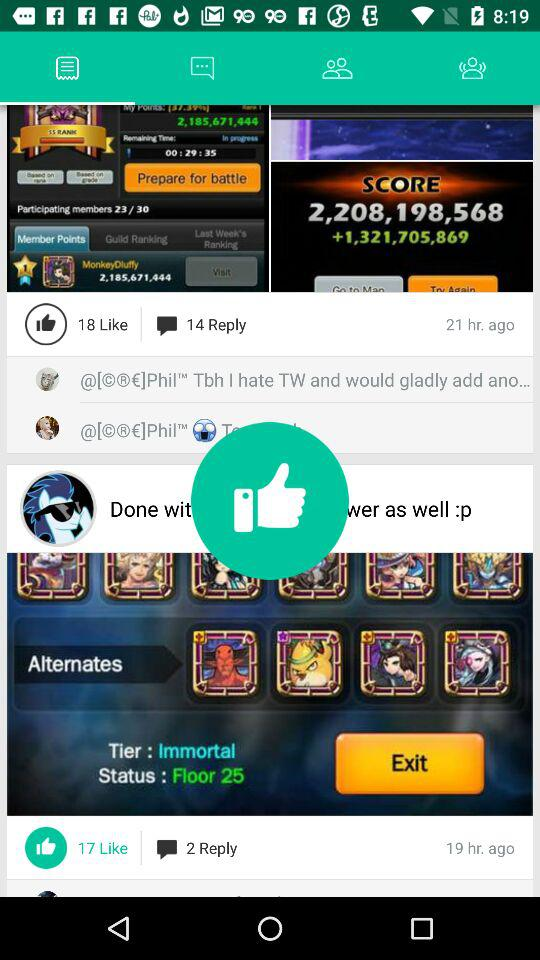How many likes are there on the post that was posted 21 hours ago? There are 18 likes. 